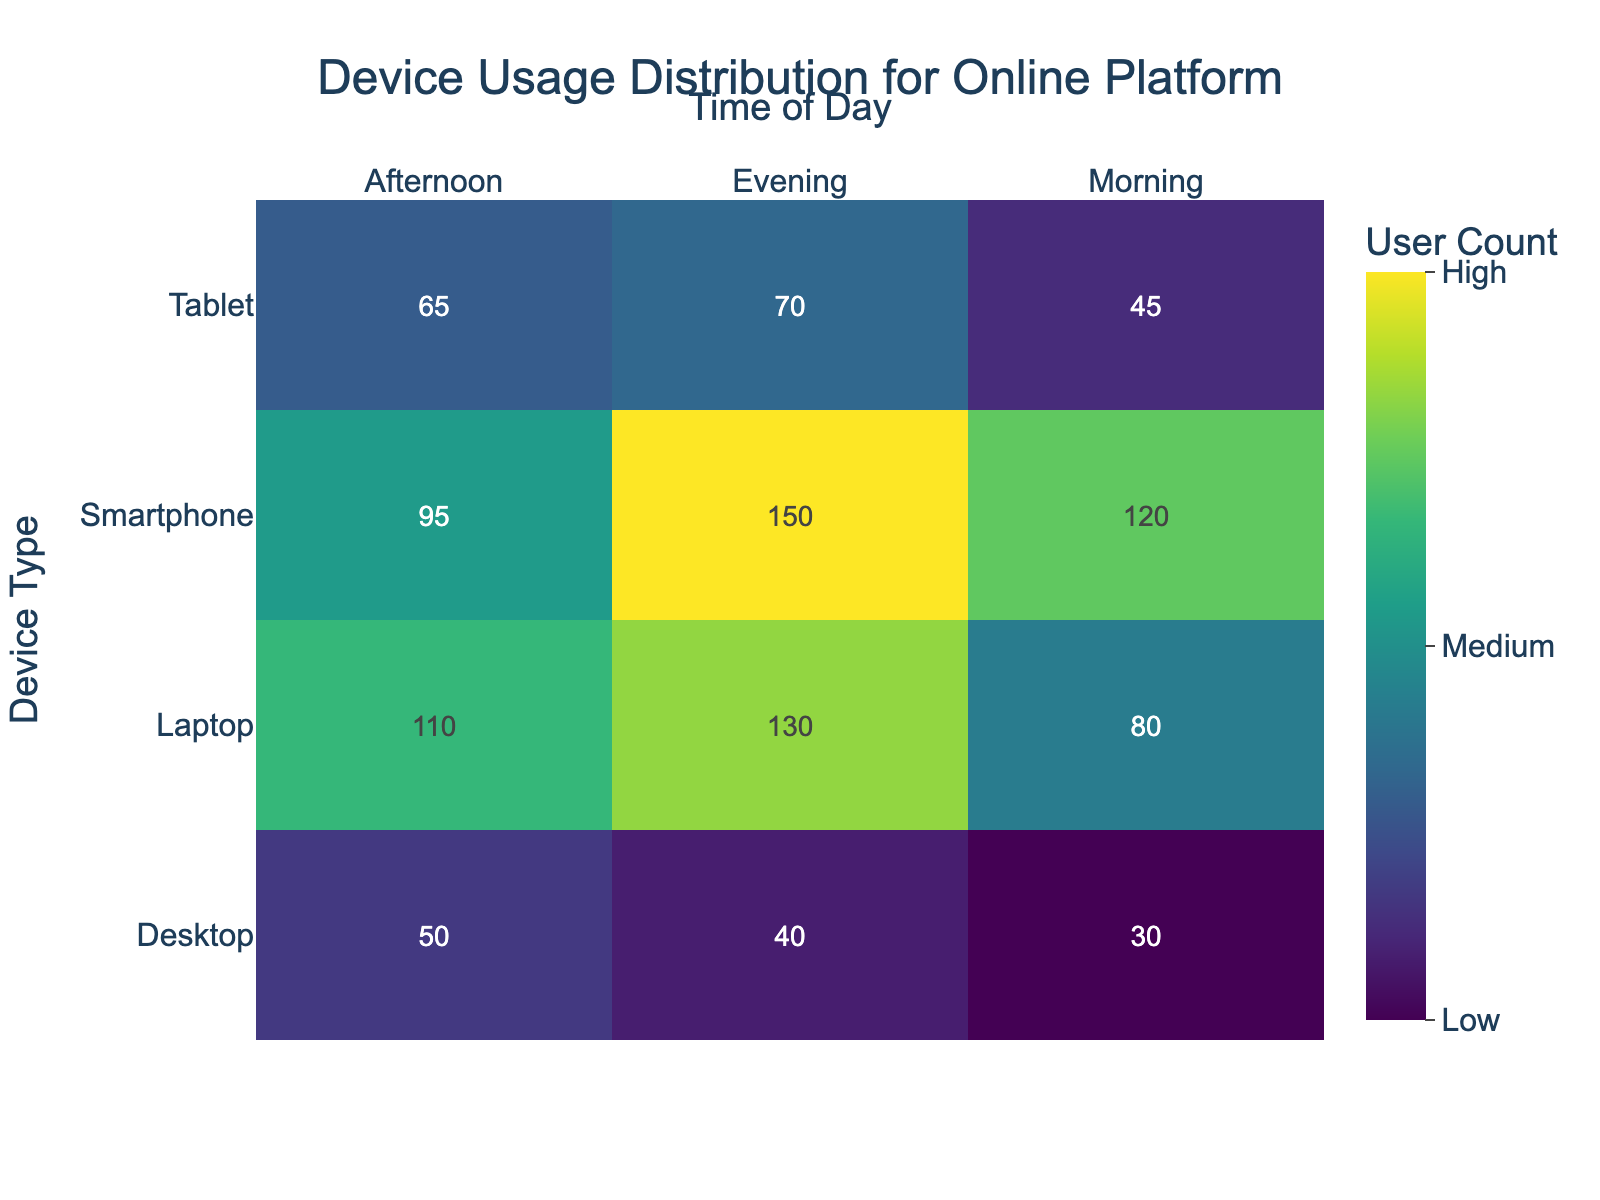What's the title of the plot? The title of the plot is located at the top of the figure. It reads "Device Usage Distribution for Online Platform".
Answer: Device Usage Distribution for Online Platform What does the x-axis represent? The x-axis at the top of the figure represents different times of the day: Morning, Afternoon, and Evening.
Answer: Time of Day Which device has the highest user count in the Evening? Locate the 'Evening' column on the x-axis and see which row (device) has the darkest cell. The Smartphone has the highest user count at 150.
Answer: Smartphone What's the user count for Desktops in the Afternoon? Find the cell at the intersection of the 'Desktop' row and the 'Afternoon' column. The value is 50.
Answer: 50 Sum the user counts for Tablets across all times of the day. Add the values from the 'Tablet' row across Morning, Afternoon, and Evening columns: 45 (Morning) + 65 (Afternoon) + 70 (Evening) = 180.
Answer: 180 Which time of day has the highest total user count? Sum the values in each column: 
Morning: 120 + 80 + 45 + 30 = 275
Afternoon: 95 + 110 + 65 + 50 = 320
Evening: 150 + 130 + 70 + 40 = 390
The Evening has the highest total user count at 390.
Answer: Evening Compare the user count for Laptops in the Morning and the Afternoon. Which is higher? Find the values in the 'Laptop' row for Morning and Afternoon. Morning has 80 users, while Afternoon has 110 users. Afternoon is higher.
Answer: Afternoon Which device has the lowest user count in the Morning? Locate the 'Morning' column on the x-axis and see which row (device) has the lightest cell. The Desktop has the lowest user count at 30.
Answer: Desktop What's the average user count for Smartphones across all times of the day? Sum the values for 'Smartphone' row: 120 (Morning) + 95 (Afternoon) + 150 (Evening) = 365. Divide by the number of entries (3): 365 / 3 = 121.67.
Answer: 121.67 Between Tablets and Desktops, which device is more used in the Evening? Compare the evening values for 'Tablet' and 'Desktop' rows. Tablet has 70 and Desktop has 40. Tablet is more used.
Answer: Tablet 